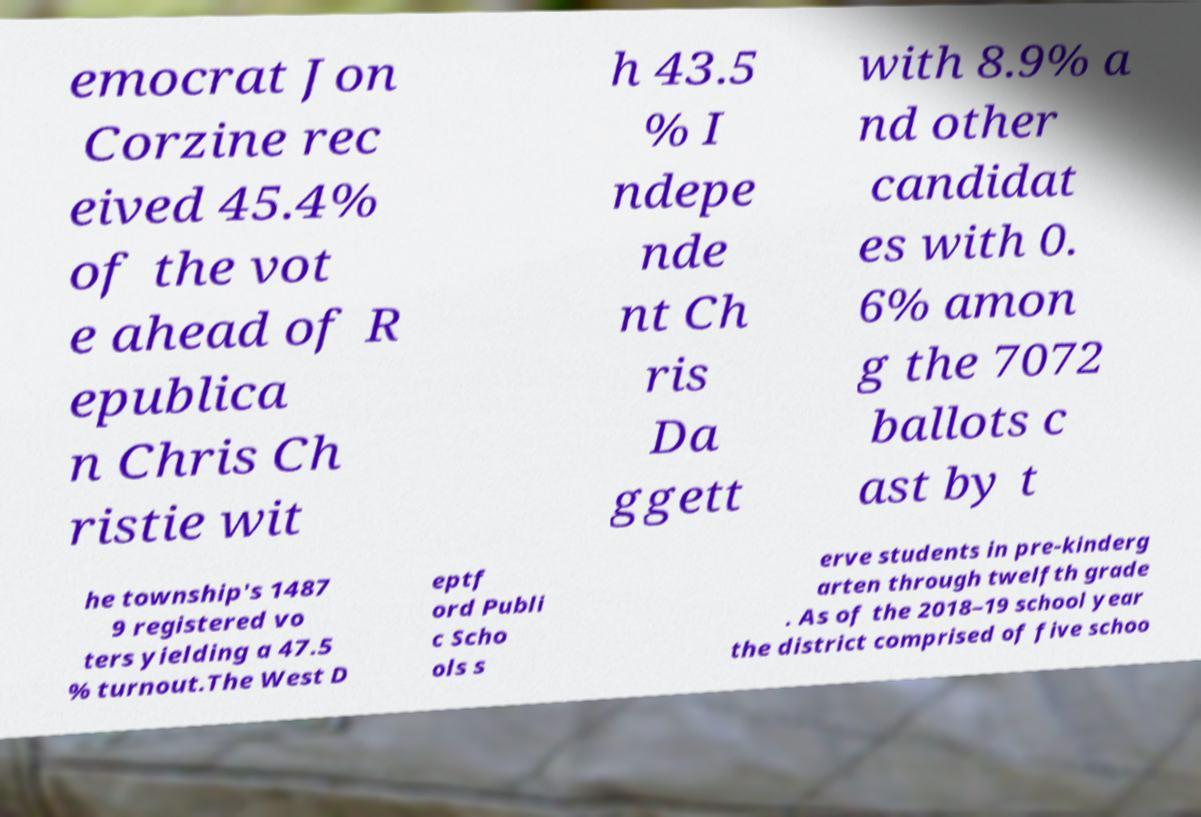What messages or text are displayed in this image? I need them in a readable, typed format. emocrat Jon Corzine rec eived 45.4% of the vot e ahead of R epublica n Chris Ch ristie wit h 43.5 % I ndepe nde nt Ch ris Da ggett with 8.9% a nd other candidat es with 0. 6% amon g the 7072 ballots c ast by t he township's 1487 9 registered vo ters yielding a 47.5 % turnout.The West D eptf ord Publi c Scho ols s erve students in pre-kinderg arten through twelfth grade . As of the 2018–19 school year the district comprised of five schoo 